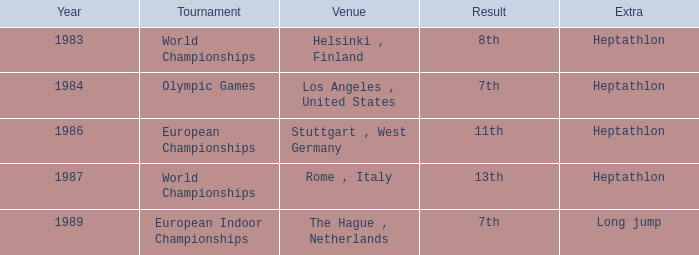How often do the olympic games take place? 1984.0. 